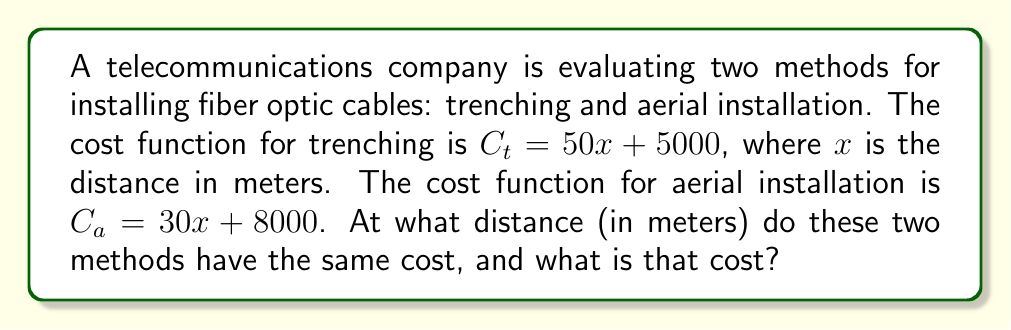Show me your answer to this math problem. To solve this problem, we need to find the point where the two cost functions are equal. This can be done using a system of equations:

1) Set up the equation:
   $$C_t = C_a$$
   $$50x + 5000 = 30x + 8000$$

2) Solve for $x$:
   $$50x + 5000 = 30x + 8000$$
   $$50x - 30x = 8000 - 5000$$
   $$20x = 3000$$
   $$x = \frac{3000}{20} = 150$$

3) The distance at which the costs are equal is 150 meters.

4) To find the cost at this point, substitute $x = 150$ into either equation:
   $$C_t = 50(150) + 5000 = 7500 + 5000 = 12500$$
   or
   $$C_a = 30(150) + 8000 = 4500 + 8000 = 12500$$

Therefore, at 150 meters, both methods cost $12,500.
Answer: 150 meters; $12,500 